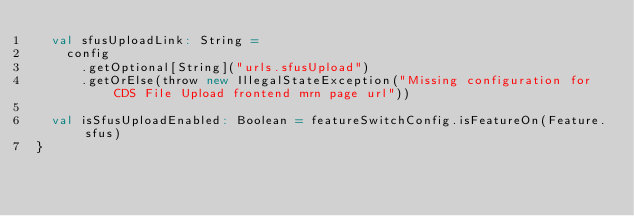<code> <loc_0><loc_0><loc_500><loc_500><_Scala_>  val sfusUploadLink: String =
    config
      .getOptional[String]("urls.sfusUpload")
      .getOrElse(throw new IllegalStateException("Missing configuration for CDS File Upload frontend mrn page url"))

  val isSfusUploadEnabled: Boolean = featureSwitchConfig.isFeatureOn(Feature.sfus)
}
</code> 